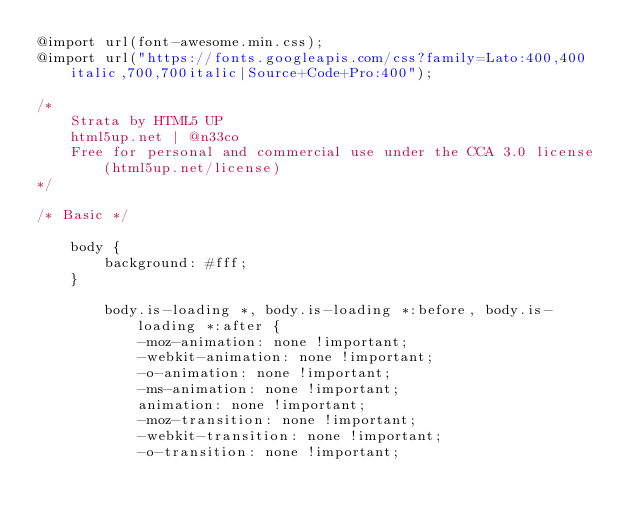<code> <loc_0><loc_0><loc_500><loc_500><_CSS_>@import url(font-awesome.min.css);
@import url("https://fonts.googleapis.com/css?family=Lato:400,400italic,700,700italic|Source+Code+Pro:400");

/*
	Strata by HTML5 UP
	html5up.net | @n33co
	Free for personal and commercial use under the CCA 3.0 license (html5up.net/license)
*/

/* Basic */

	body {
		background: #fff;
	}

		body.is-loading *, body.is-loading *:before, body.is-loading *:after {
			-moz-animation: none !important;
			-webkit-animation: none !important;
			-o-animation: none !important;
			-ms-animation: none !important;
			animation: none !important;
			-moz-transition: none !important;
			-webkit-transition: none !important;
			-o-transition: none !important;</code> 